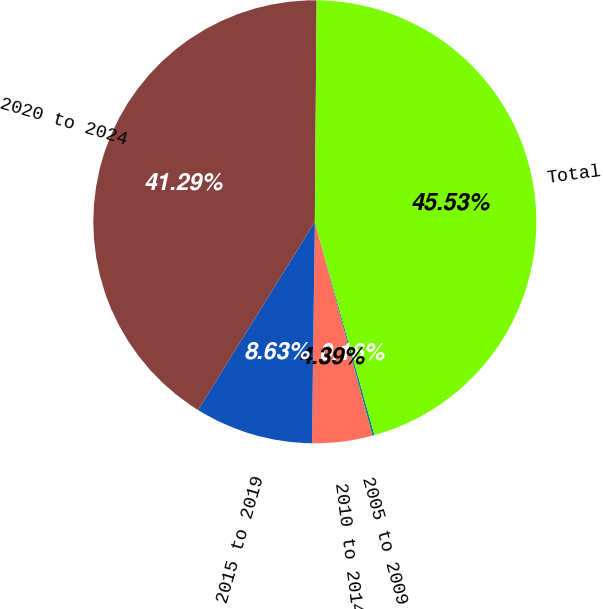Convert chart to OTSL. <chart><loc_0><loc_0><loc_500><loc_500><pie_chart><fcel>2005 to 2009<fcel>2010 to 2014<fcel>2015 to 2019<fcel>2020 to 2024<fcel>Total<nl><fcel>0.16%<fcel>4.39%<fcel>8.63%<fcel>41.29%<fcel>45.53%<nl></chart> 